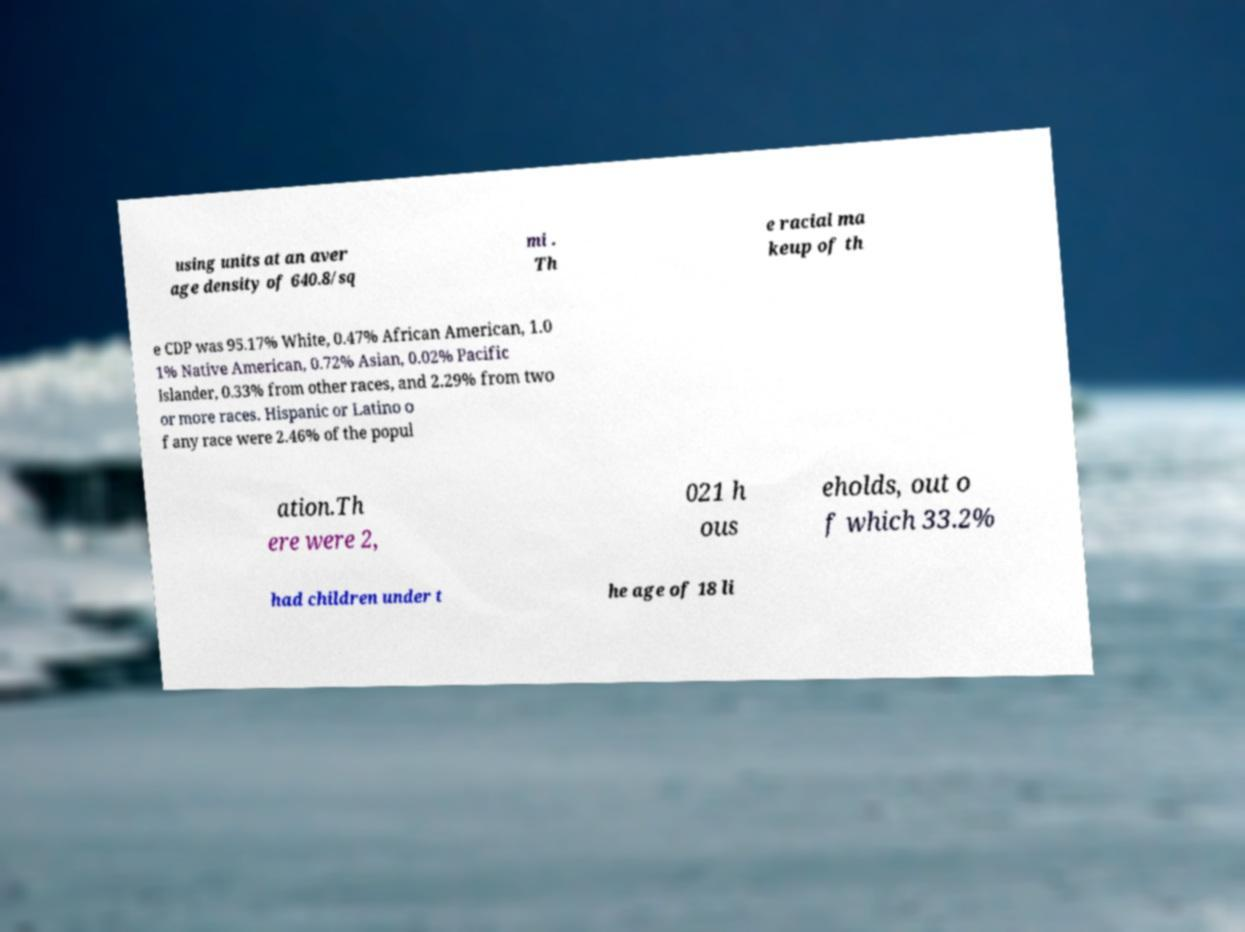Can you accurately transcribe the text from the provided image for me? using units at an aver age density of 640.8/sq mi . Th e racial ma keup of th e CDP was 95.17% White, 0.47% African American, 1.0 1% Native American, 0.72% Asian, 0.02% Pacific Islander, 0.33% from other races, and 2.29% from two or more races. Hispanic or Latino o f any race were 2.46% of the popul ation.Th ere were 2, 021 h ous eholds, out o f which 33.2% had children under t he age of 18 li 